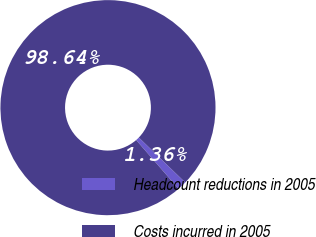Convert chart. <chart><loc_0><loc_0><loc_500><loc_500><pie_chart><fcel>Headcount reductions in 2005<fcel>Costs incurred in 2005<nl><fcel>1.36%<fcel>98.64%<nl></chart> 